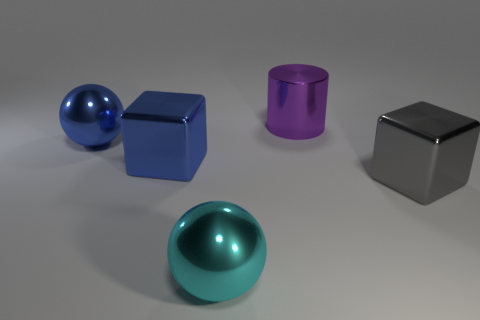Add 3 small cyan rubber cylinders. How many objects exist? 8 Subtract all balls. How many objects are left? 3 Subtract 0 brown cylinders. How many objects are left? 5 Subtract all large gray metallic cylinders. Subtract all metallic things. How many objects are left? 0 Add 2 large gray blocks. How many large gray blocks are left? 3 Add 5 gray things. How many gray things exist? 6 